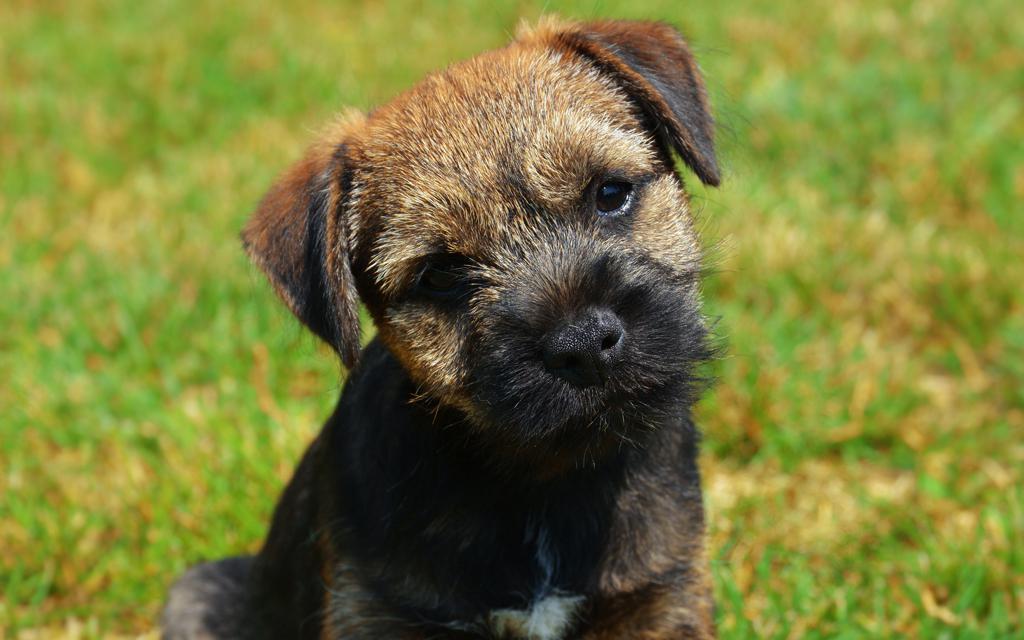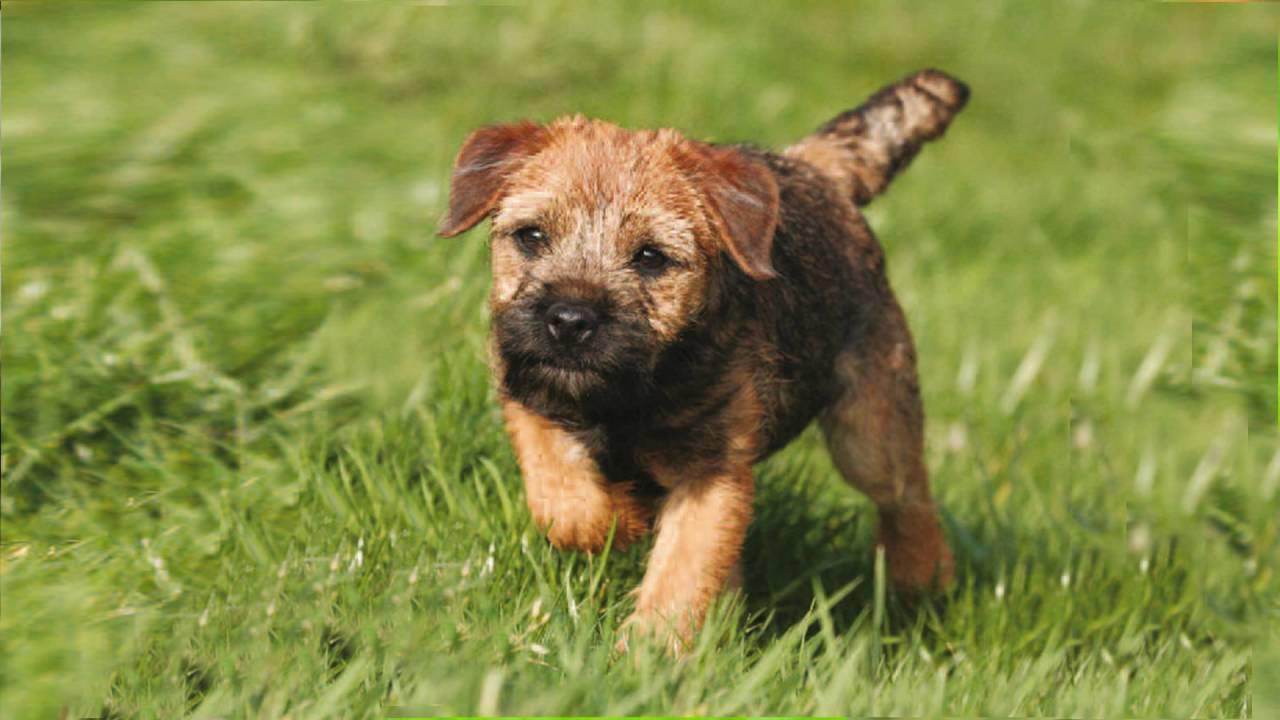The first image is the image on the left, the second image is the image on the right. Evaluate the accuracy of this statement regarding the images: "A collar is visible on the dog in one of the images.". Is it true? Answer yes or no. No. 